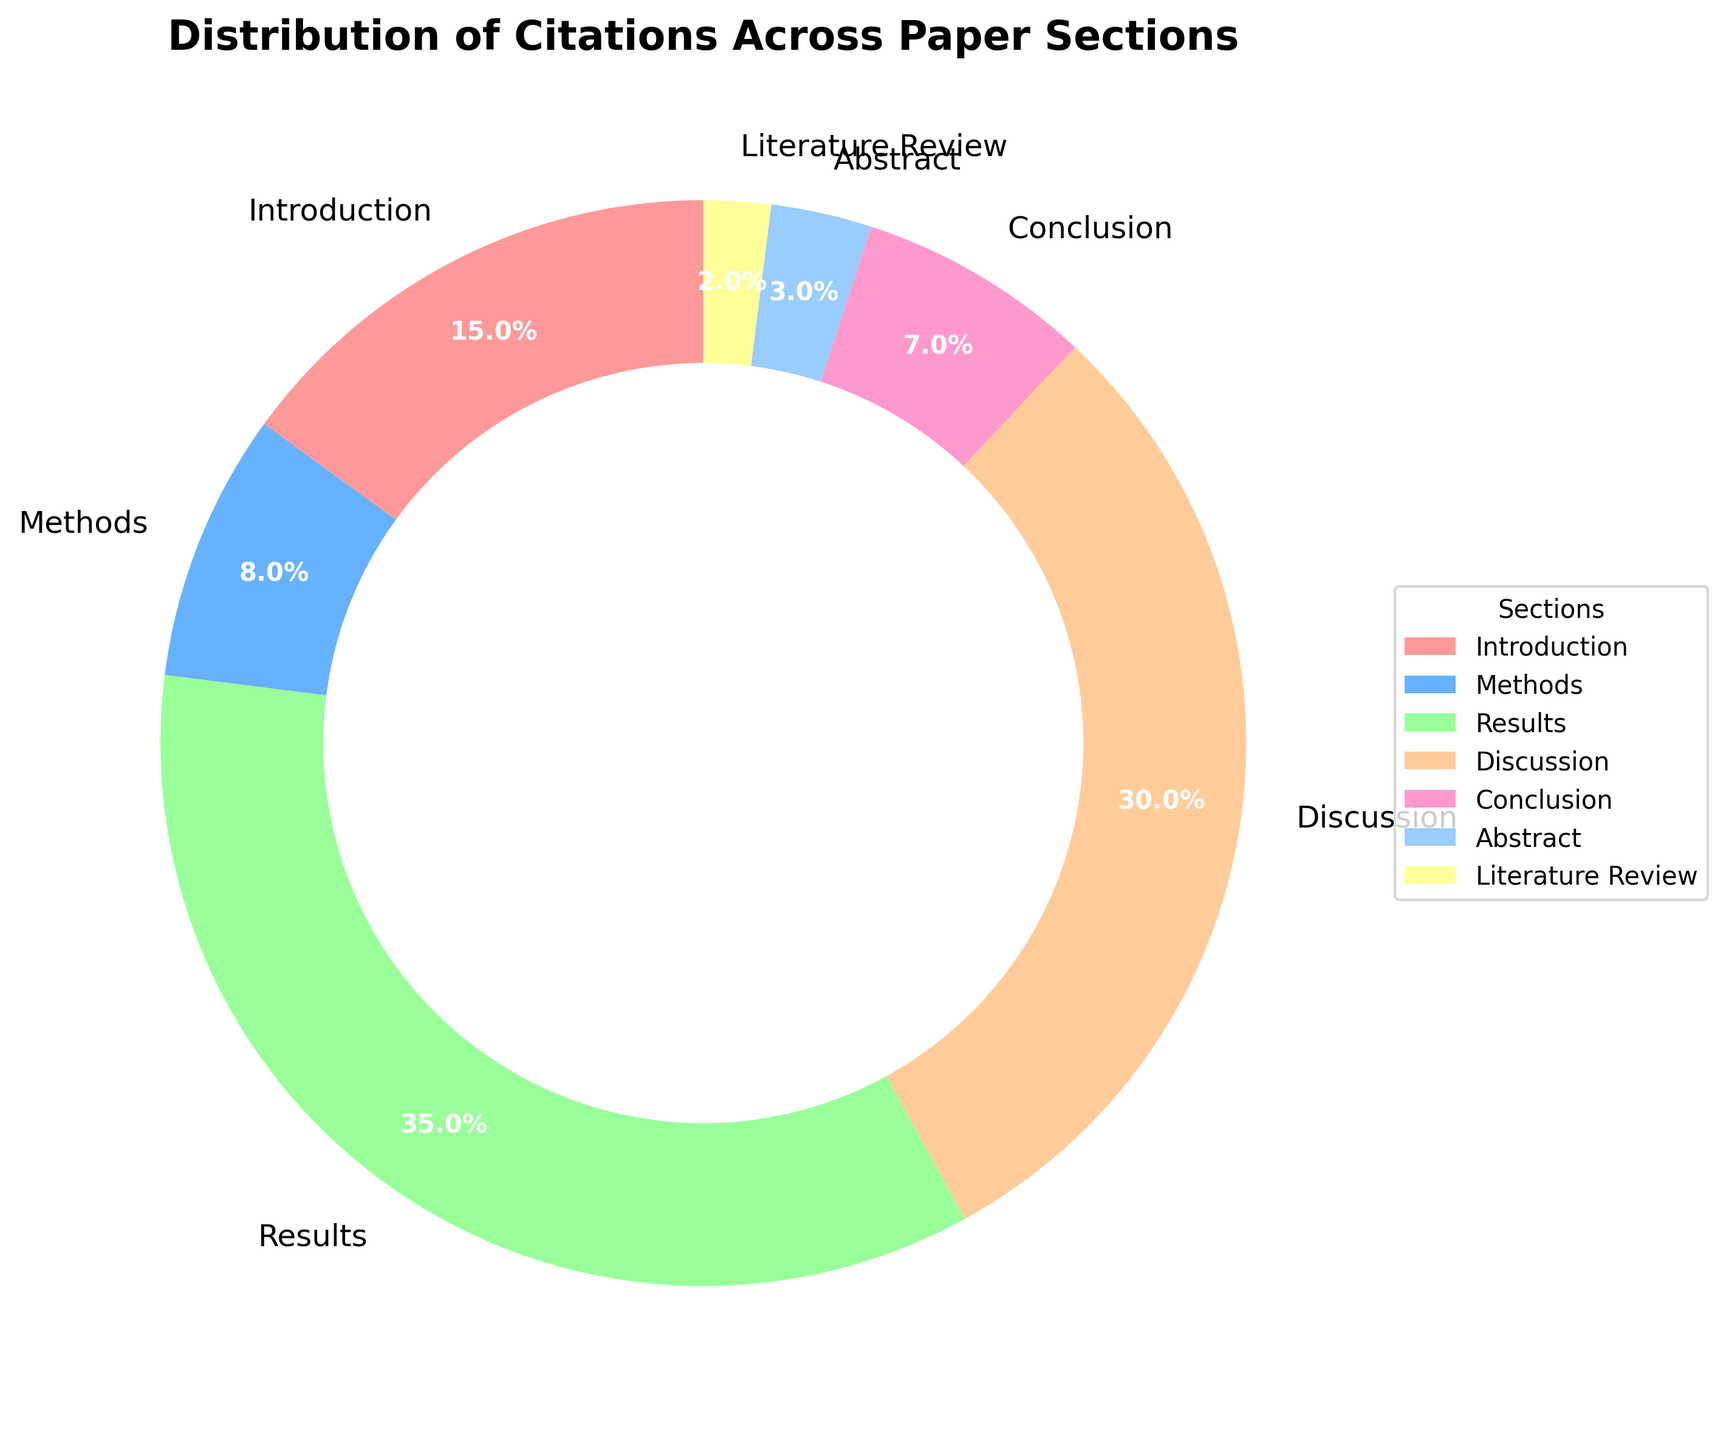What's the section with the highest percentage of citations? Look at the pie chart and identify the section with the largest slice. The section labeled "Results" has a percentage of 35%, which is the highest among all sections.
Answer: Results How do the citations in the Discussion section compare to the Methods section? Compare the percentages shown for the Discussion and Methods sections. The Discussion section has 30% while the Methods section has 8%. The Discussion section has a higher percentage of citations than the Methods section.
Answer: The Discussion section has more citations What is the combined percentage of citations in the Introduction and Conclusion sections? Add the percentages of the Introduction and Conclusion sections. 15% (Introduction) + 7% (Conclusion) = 22%.
Answer: 22% Which section has the smallest share of citations? Look through the pie chart for the section with the smallest percentage. The Literature Review section has the smallest slice with 2%.
Answer: Literature Review What percentage of citations are in the Abstract and Literature Review combined? Sum the percentages for both the Abstract and Literature Review sections. 3% (Abstract) + 2% (Literature Review) = 5%.
Answer: 5% Is the percentage of citations in the Results section greater than the combined percentages of Methods and Conclusion sections? Compare the percentage of the Results section with the sum of Methods and Conclusion sections. Results is 35%. Methods (8%) + Conclusion (7%) = 15%. 35% (Results) is greater than 15% (Methods + Conclusion).
Answer: Yes How does the number of citations in the Abstract compare to the Introduction? Compare the percentage slices in the chart. The Abstract has 3% and the Introduction has 15%. The Introduction has a larger percentage than the Abstract.
Answer: The Introduction has more citations What is the difference in the percentages between the sections with the highest and lowest citations? Identify the highest and lowest percentages in the chart: Results at 35% and Literature Review at 2%. Calculate the difference: 35% - 2% = 33%.
Answer: 33% Are there more citations in the Results section or in the combined Introduction and Discussion sections? Compare the percentage of the Results section with the sum of the Introduction and Discussion sections. Results is 35%, Introduction (15%) + Discussion (30%) = 45%. The combined sections have 45%, which is more than the Results section's 35%.
Answer: Combined sections What percentage of citations is in sections other than Results and Discussion? Subtract the percentages of Results and Discussion from 100%. 100% - 35% (Results) - 30% (Discussion) = 35%.
Answer: 35% 